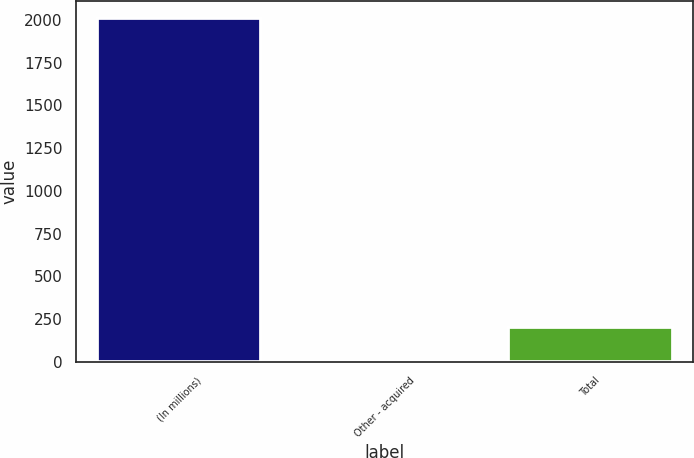<chart> <loc_0><loc_0><loc_500><loc_500><bar_chart><fcel>(In millions)<fcel>Other - acquired<fcel>Total<nl><fcel>2011<fcel>5<fcel>205.6<nl></chart> 